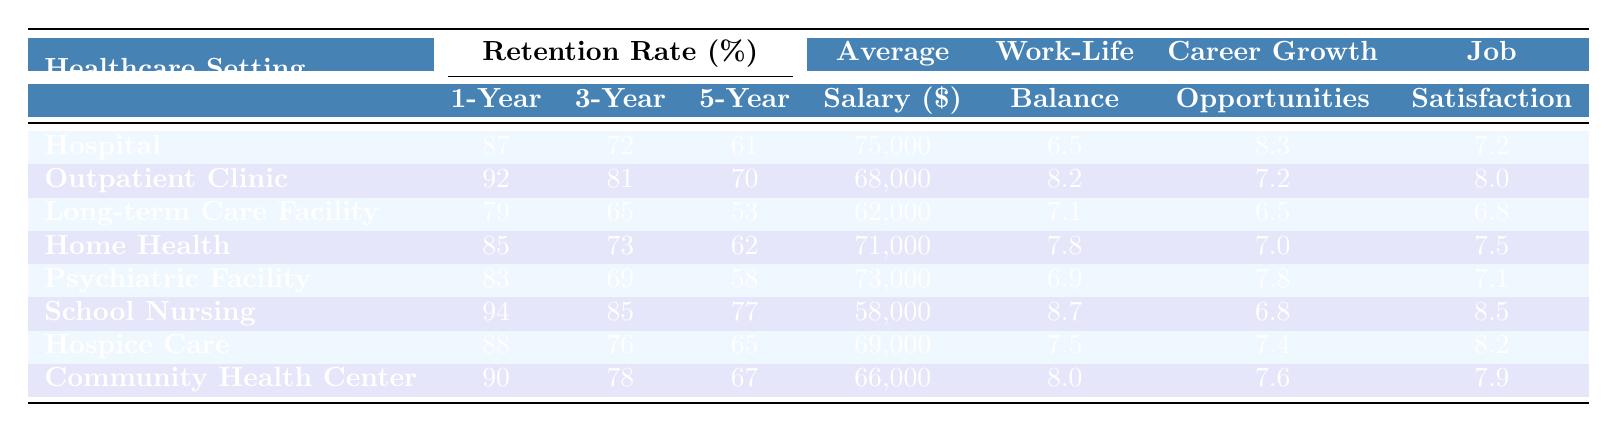What's the 1-Year retention rate for School Nursing? According to the table, the 1-Year retention rate for School Nursing is listed under that category, which is 94%.
Answer: 94% Which healthcare setting has the highest 5-Year retention rate? The highest 5-Year retention rate is found in Outpatient Clinic, which has a rate of 70%.
Answer: Outpatient Clinic Is the average salary in Long-term Care Facility higher than in Home Health? The average salary for Long-term Care Facility is $62,000, while Home Health has an average of $71,000. Since $62,000 is less than $71,000, the statement is false.
Answer: No What is the difference between the 3-Year retention rate of Hospital and Community Health Center? The 3-Year retention rate for Hospital is 72% and for Community Health Center is 78%. The difference can be calculated as 78% - 72% = 6%.
Answer: 6% What is the average Work-Life Balance Rating across all healthcare settings? To find the average, we sum the Work-Life Balance Ratings (6.5 + 8.2 + 7.1 + 7.8 + 6.9 + 8.7 + 7.5 + 8.0 = 60.7) and divide by the number of settings (8). This gives 60.7 / 8 = 7.5875, which can be rounded to 7.59.
Answer: 7.59 Which healthcare setting has the lowest job satisfaction rating? Looking at the Job Satisfaction Ratings, Long-term Care Facility has the lowest rating at 6.8.
Answer: Long-term Care Facility Is the average salary in Hospice Care greater than the average in Hospital? The average salary for Hospice Care is $69,000, while for Hospital it is $75,000. Since $69,000 is less than $75,000, the statement is false.
Answer: No How do the Career Growth Opportunities ratings compare between Outpatient Clinic and School Nursing? Outpatient Clinic has a rating of 7.2, while School Nursing has a rating of 6.8. Therefore, Outpatient Clinic has a higher rating than School Nursing.
Answer: Outpatient Clinic has a higher rating What is the difference in 1-Year retention rates between the highest and lowest rates among the facilities? The highest 1-Year retention rate is 94% (School Nursing) and the lowest is 79% (Long-term Care Facility). The difference is 94% - 79% = 15%.
Answer: 15% What is the average Job Satisfaction Rating for those settings with a Work-Life Balance Rating greater than 7.5? The settings with a Work-Life Balance Rating greater than 7.5 are Outpatient Clinic (8.2), School Nursing (8.7), Hospice Care (7.5), and Community Health Center (8.0). The ratings are summed as 8.2 + 8.7 + 7.5 + 8.0 = 32.4, and divided by 4 gives us 32.4 / 4 = 8.1.
Answer: 8.1 